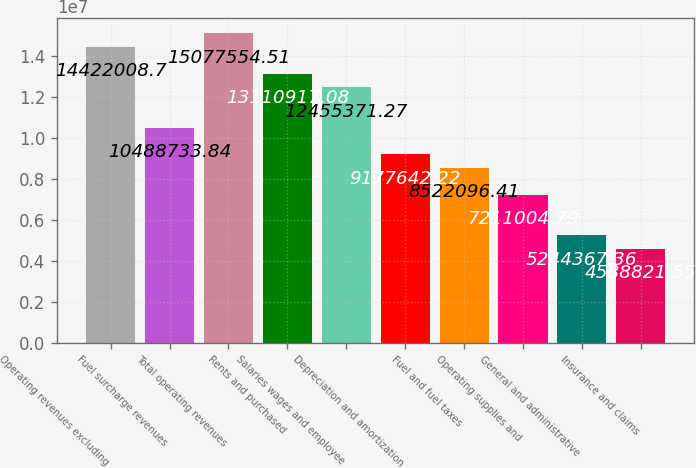Convert chart. <chart><loc_0><loc_0><loc_500><loc_500><bar_chart><fcel>Operating revenues excluding<fcel>Fuel surcharge revenues<fcel>Total operating revenues<fcel>Rents and purchased<fcel>Salaries wages and employee<fcel>Depreciation and amortization<fcel>Fuel and fuel taxes<fcel>Operating supplies and<fcel>General and administrative<fcel>Insurance and claims<nl><fcel>1.4422e+07<fcel>1.04887e+07<fcel>1.50776e+07<fcel>1.31109e+07<fcel>1.24554e+07<fcel>9.17764e+06<fcel>8.5221e+06<fcel>7.211e+06<fcel>5.24437e+06<fcel>4.58882e+06<nl></chart> 